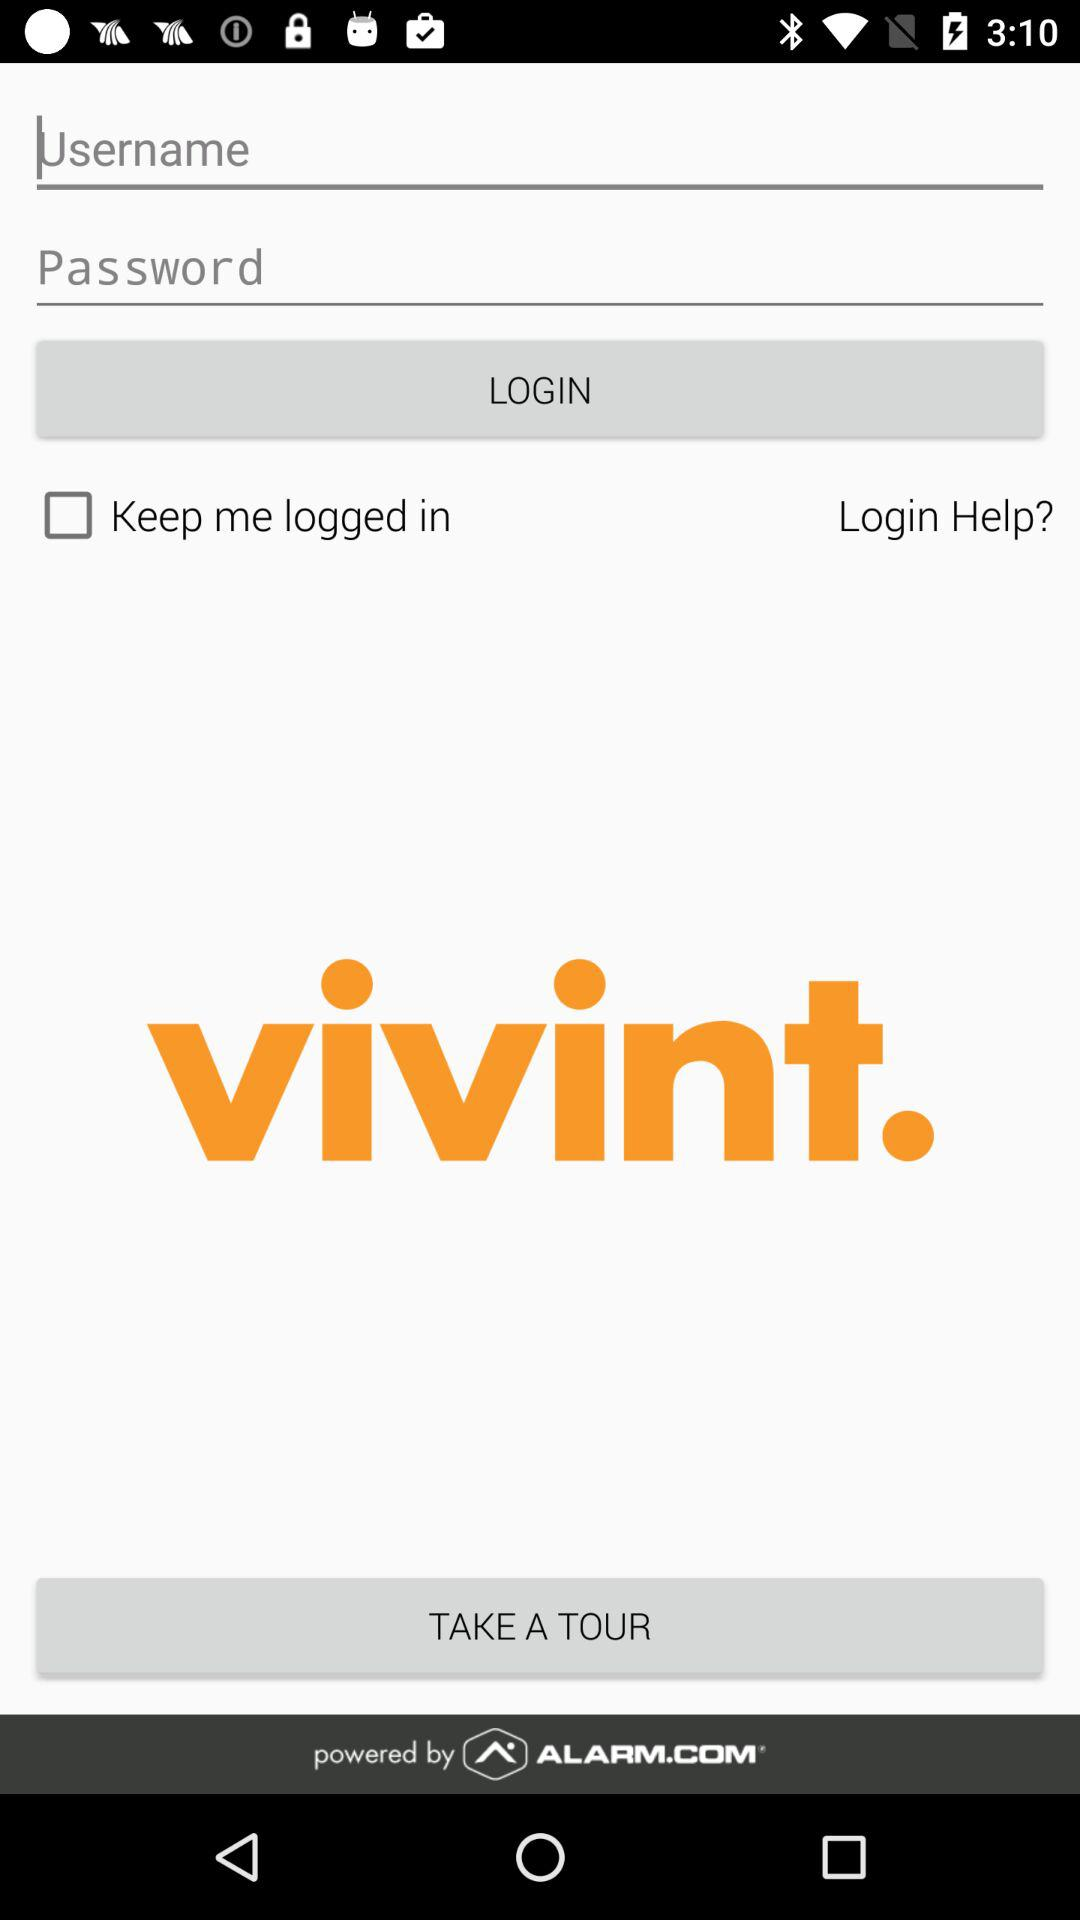What is the app name? The app name is "vivint". 